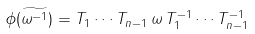Convert formula to latex. <formula><loc_0><loc_0><loc_500><loc_500>\phi ( \widetilde { \omega ^ { - 1 } } ) = T _ { 1 } \cdots T _ { n - 1 } \, \omega \, T _ { 1 } ^ { - 1 } \cdots T _ { n - 1 } ^ { - 1 }</formula> 